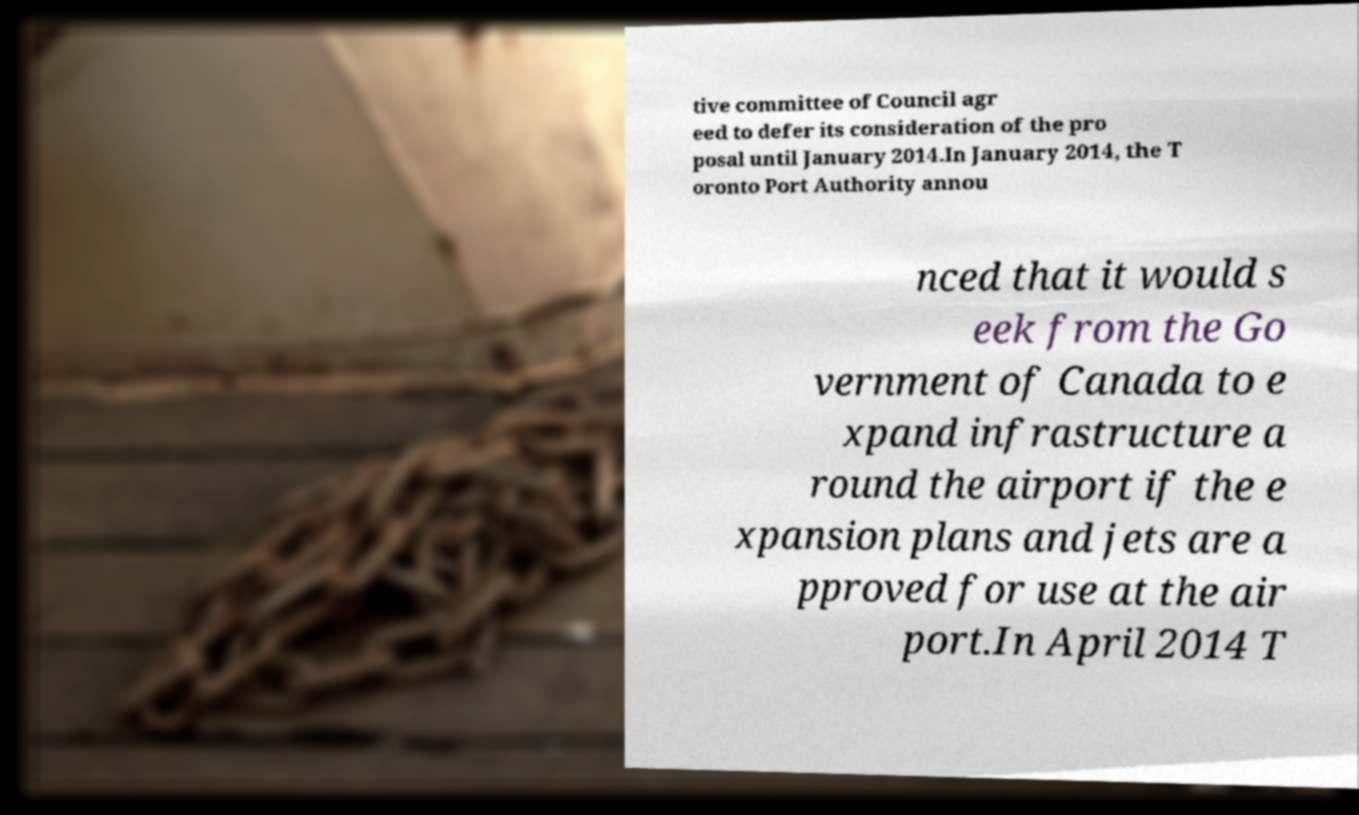Can you accurately transcribe the text from the provided image for me? tive committee of Council agr eed to defer its consideration of the pro posal until January 2014.In January 2014, the T oronto Port Authority annou nced that it would s eek from the Go vernment of Canada to e xpand infrastructure a round the airport if the e xpansion plans and jets are a pproved for use at the air port.In April 2014 T 